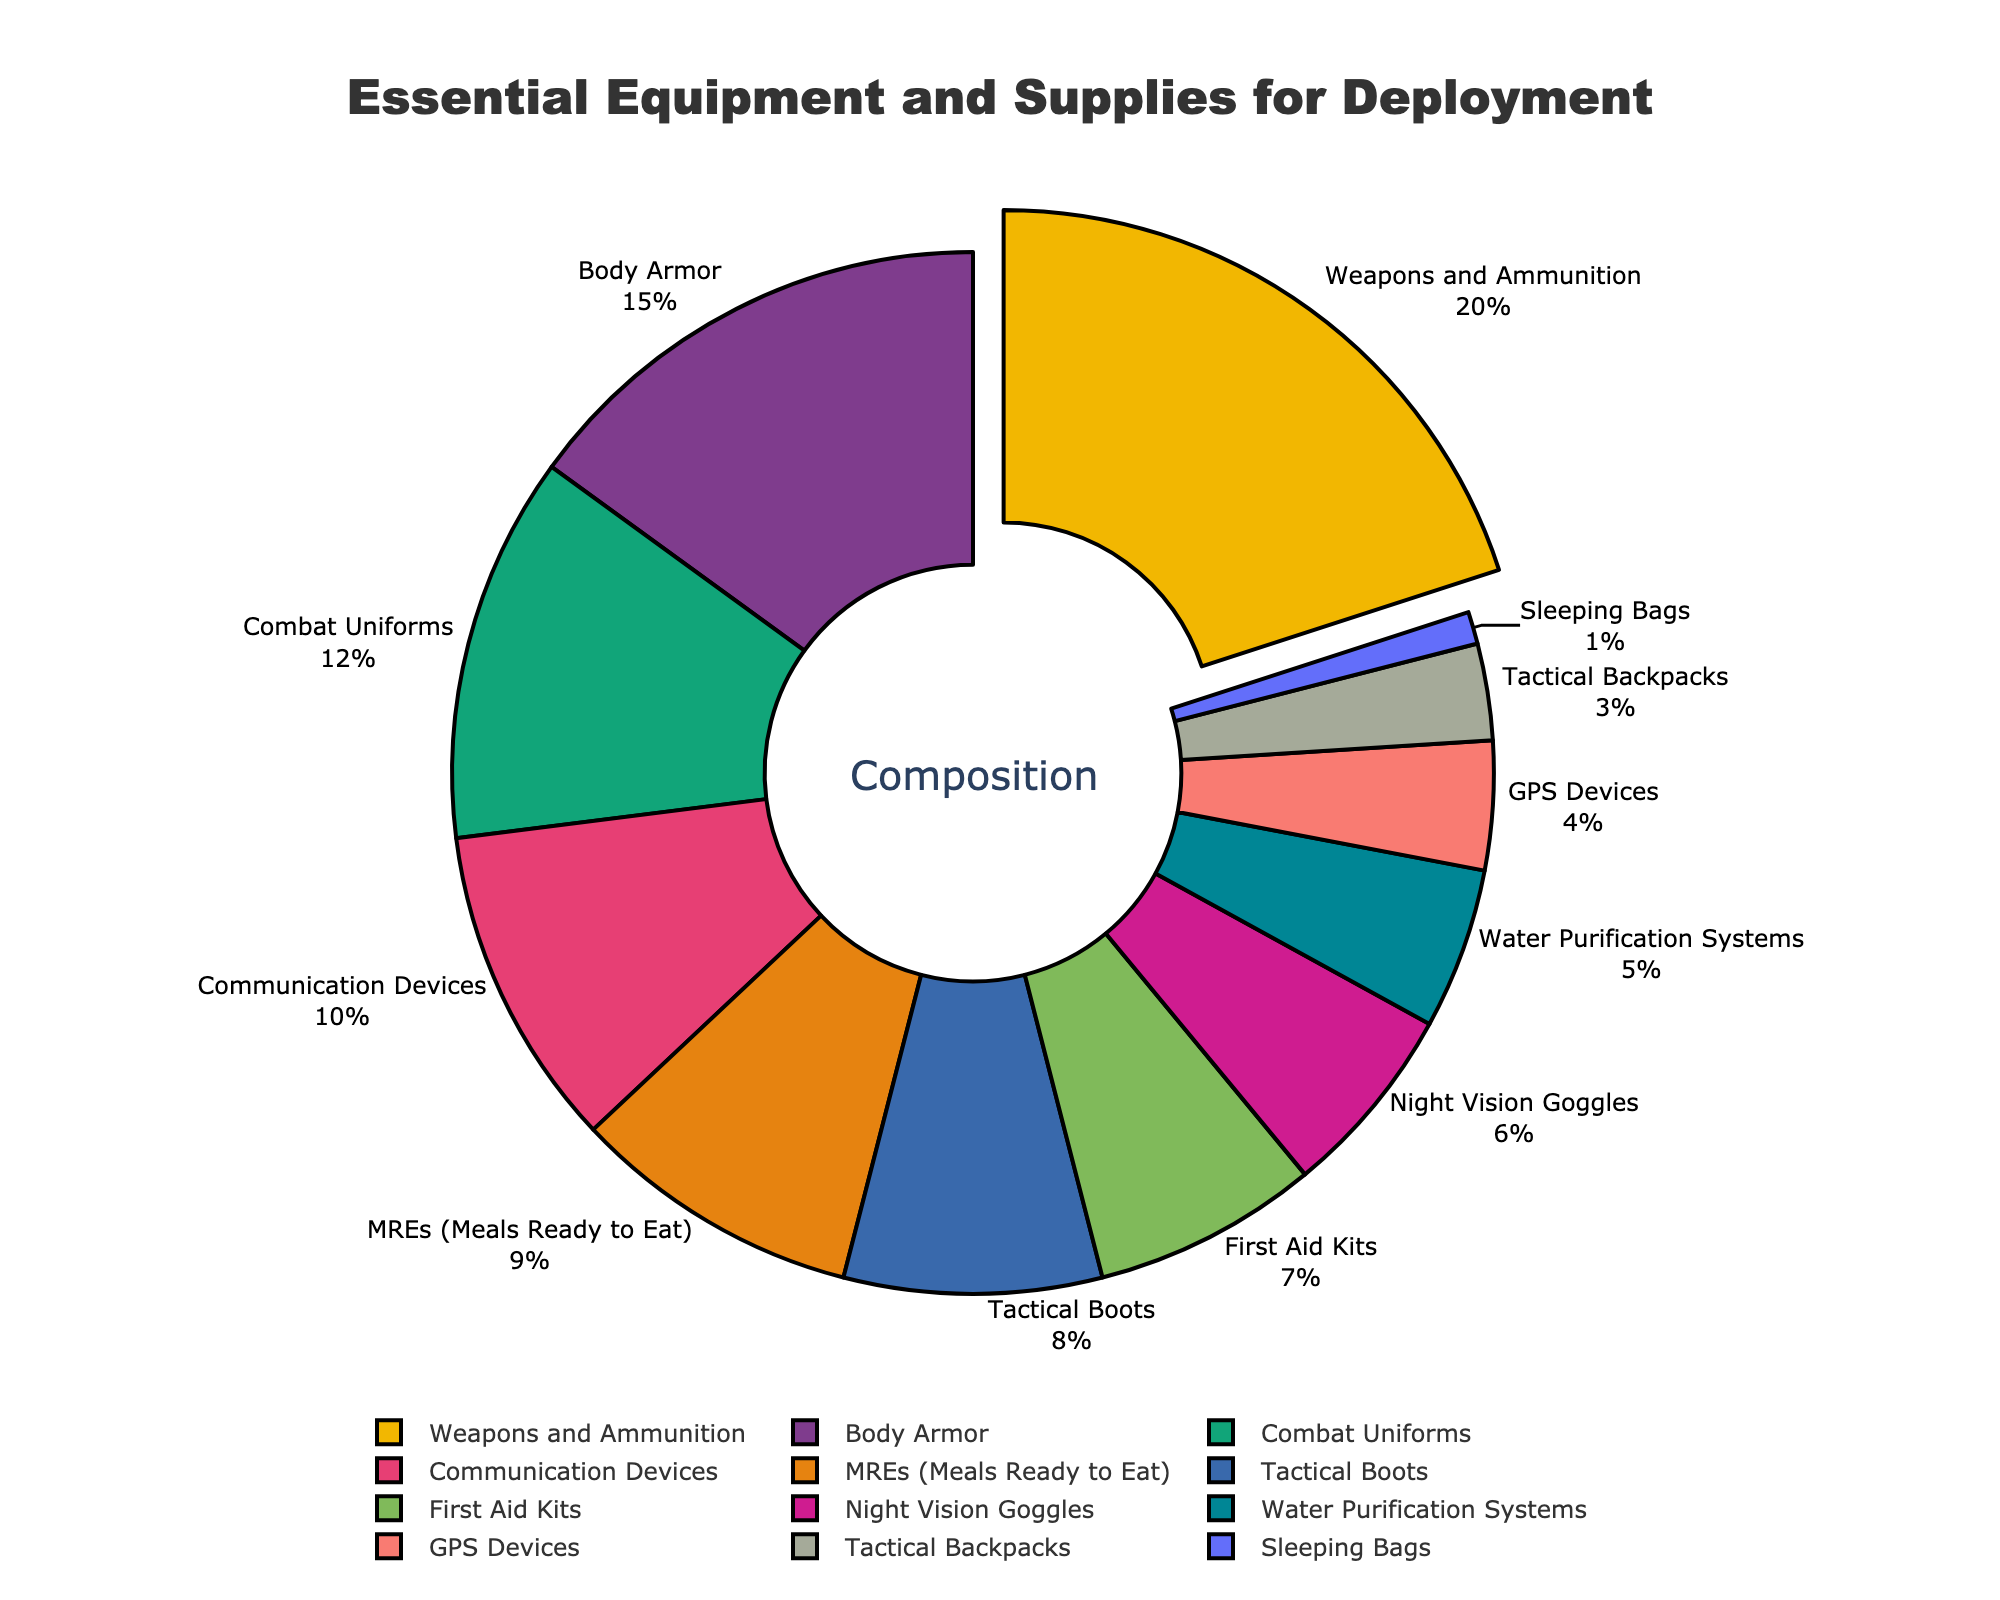Which equipment category has the highest percentage? The segment with the largest percentage is visually pulled out slightly from the others, representing Weapons and Ammunition, which accounts for 20% of the total.
Answer: Weapons and Ammunition What is the combined percentage of Combat Uniforms and Tactical Boots? From the chart, Combat Uniforms account for 12% and Tactical Boots account for 8%. Adding these percentages gives 12% + 8% = 20%.
Answer: 20% How does the percentage of GPS Devices compare to Night Vision Goggles? Night Vision Goggles are marked at 6%, while GPS Devices are marked at 4%, indicating that Night Vision Goggles have a higher percentage.
Answer: Night Vision Goggles have a higher percentage Which equipment types each constitute less than 5% of the total? Examining the chart, we see that Water Purification Systems (5%), GPS Devices (4%), Tactical Backpacks (3%), and Sleeping Bags (1%) each constitute less than 5% of the total.
Answer: Water Purification Systems, GPS Devices, Tactical Backpacks, and Sleeping Bags What's the total percentage of the three smallest categories combined? The smallest three categories are Sleeping Bags (1%), Tactical Backpacks (3%), and GPS Devices (4%). Adding these yields 1% + 3% + 4% = 8%.
Answer: 8% Which categories together make up more than 50% of the total percentage? Starting from the largest segment, Weapons and Ammunition (20%), Body Armor (15%), Combat Uniforms (12%), and Communication Devices (10%) sum to 20% + 15% + 12% + 10% = 57%, which is more than 50%.
Answer: Weapons and Ammunition, Body Armor, Combat Uniforms, Communication Devices What is the visual cue used to highlight the category with the maximum percentage? The figure uses a pulling effect for the segment with the maximum percentage, which is Weapons and Ammunition at 20%.
Answer: Pulling effect How much larger is the percentage of MREs (Meals Ready to Eat) compared to First Aid Kits? MREs account for 9% while First Aid Kits account for 7%. The difference is 9% - 7% = 2%.
Answer: 2% Which category has the closest percentage to that of Communication Devices? Communication Devices make up 10%. Comparing the other categories, Body Armor at 15% and Combat Uniforms at 12% are further away, but MREs at 9% is the closest.
Answer: MREs (Meals Ready to Eat) What percentage does the ‘Other’ category (consisting of remaining smaller categories) sum up to? Combining Water Purification Systems (5%), Night Vision Goggles (6%), GPS Devices (4%), Tactical Backpacks (3%), and Sleeping Bags (1%) results in 5% + 6% + 4% + 3% + 1% = 19%.
Answer: 19% 